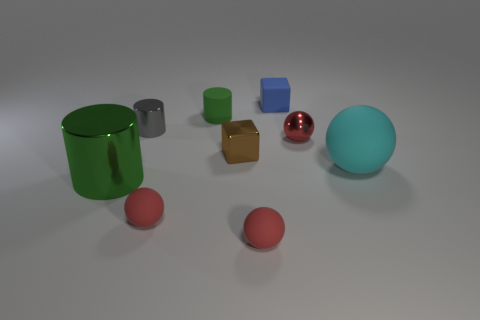Subtract all blue cylinders. How many red balls are left? 3 Subtract 1 balls. How many balls are left? 3 Subtract all brown spheres. Subtract all purple blocks. How many spheres are left? 4 Add 1 tiny brown metal objects. How many objects exist? 10 Subtract all spheres. How many objects are left? 5 Subtract 0 green cubes. How many objects are left? 9 Subtract all small brown metal things. Subtract all gray shiny objects. How many objects are left? 7 Add 4 balls. How many balls are left? 8 Add 4 large objects. How many large objects exist? 6 